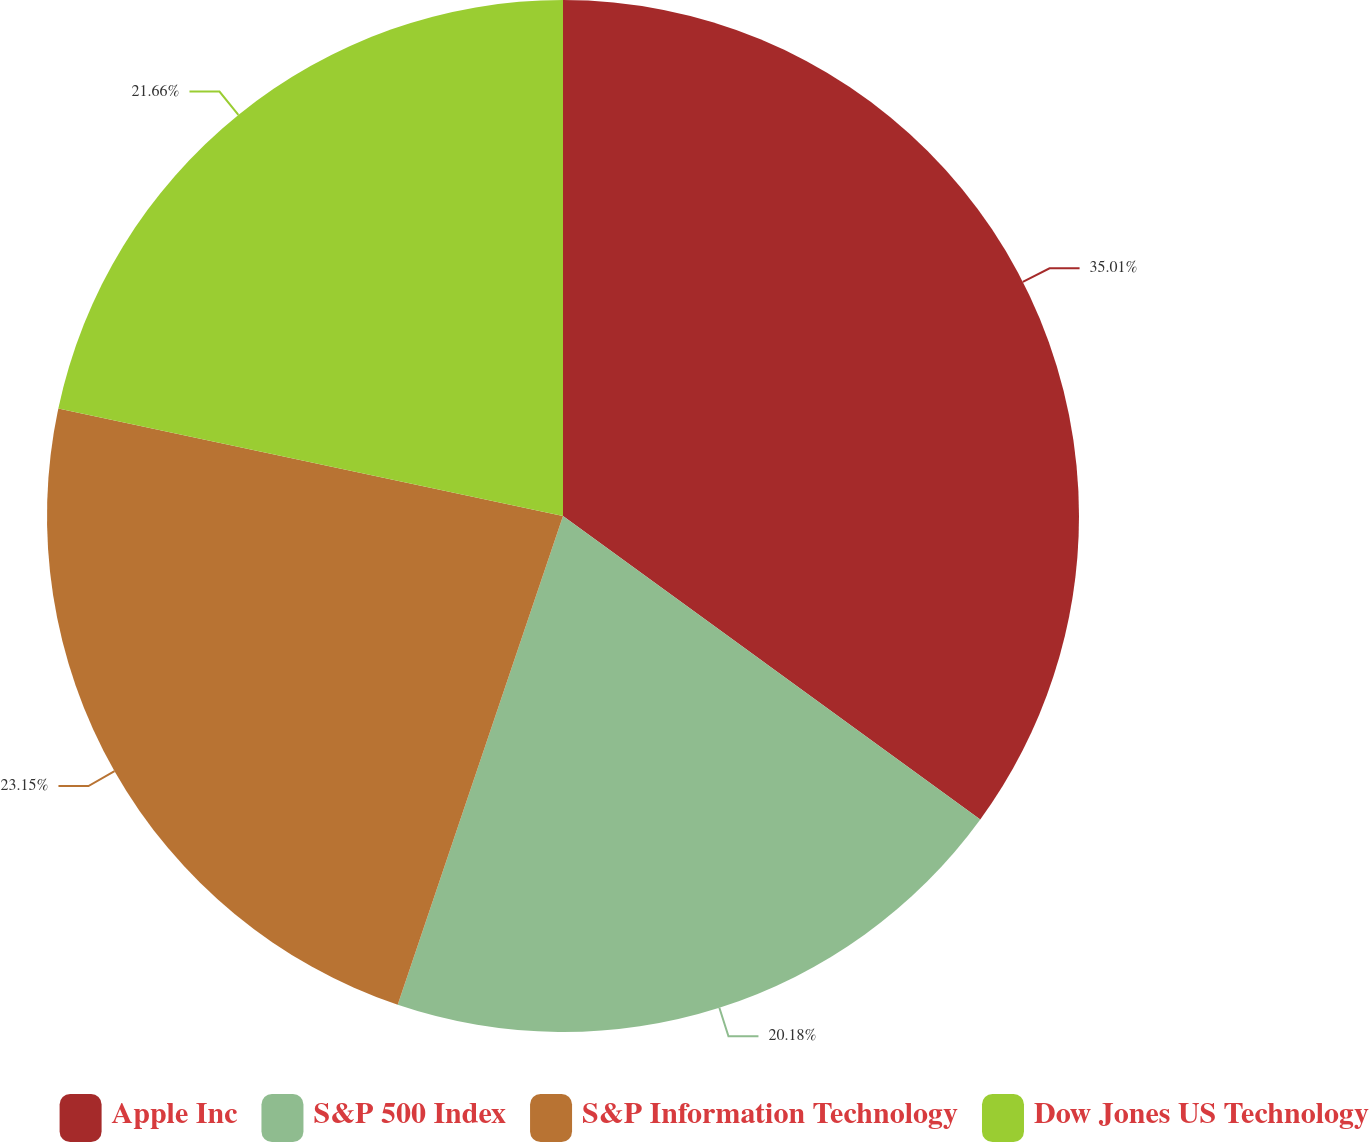Convert chart to OTSL. <chart><loc_0><loc_0><loc_500><loc_500><pie_chart><fcel>Apple Inc<fcel>S&P 500 Index<fcel>S&P Information Technology<fcel>Dow Jones US Technology<nl><fcel>35.01%<fcel>20.18%<fcel>23.15%<fcel>21.66%<nl></chart> 